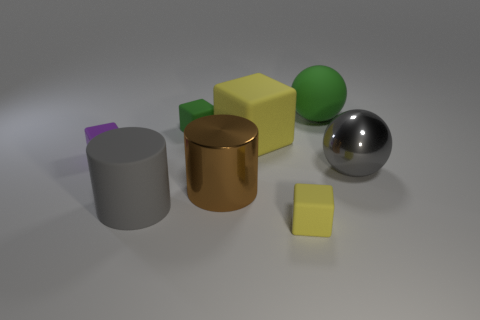Subtract all brown balls. How many yellow blocks are left? 2 Subtract all small cubes. How many cubes are left? 1 Subtract 2 blocks. How many blocks are left? 2 Subtract all cyan blocks. Subtract all gray spheres. How many blocks are left? 4 Add 1 green objects. How many objects exist? 9 Subtract all big gray shiny objects. Subtract all tiny matte blocks. How many objects are left? 4 Add 7 brown metal objects. How many brown metal objects are left? 8 Add 3 big purple metal cubes. How many big purple metal cubes exist? 3 Subtract 0 yellow cylinders. How many objects are left? 8 Subtract all cylinders. How many objects are left? 6 